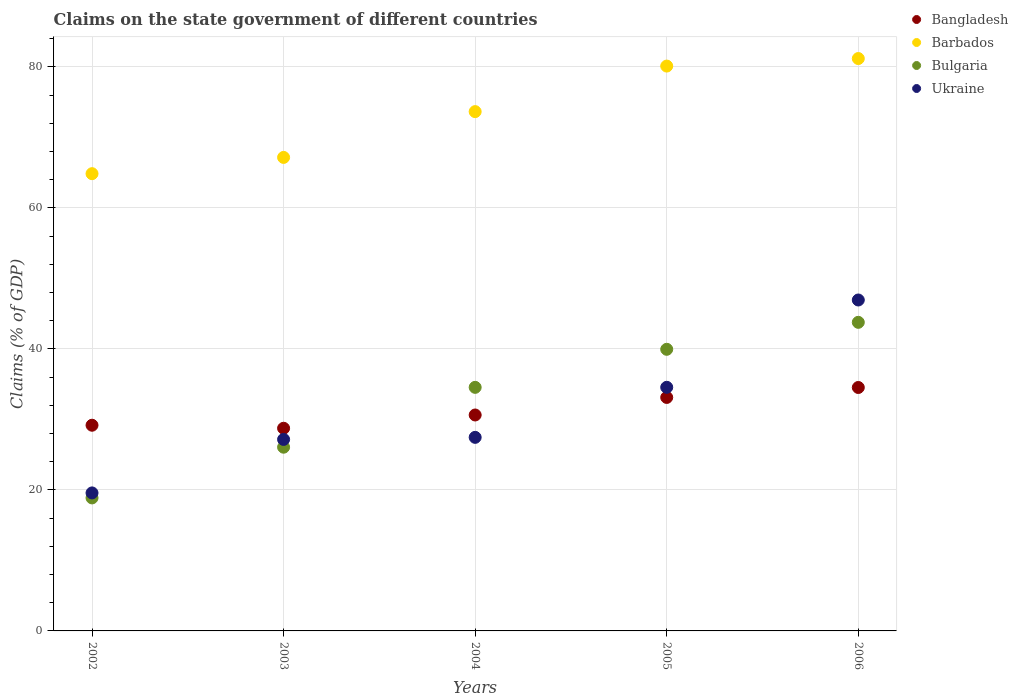How many different coloured dotlines are there?
Offer a terse response. 4. What is the percentage of GDP claimed on the state government in Ukraine in 2005?
Keep it short and to the point. 34.55. Across all years, what is the maximum percentage of GDP claimed on the state government in Bangladesh?
Your answer should be very brief. 34.52. Across all years, what is the minimum percentage of GDP claimed on the state government in Bangladesh?
Offer a terse response. 28.74. In which year was the percentage of GDP claimed on the state government in Bulgaria minimum?
Provide a succinct answer. 2002. What is the total percentage of GDP claimed on the state government in Bangladesh in the graph?
Make the answer very short. 156.18. What is the difference between the percentage of GDP claimed on the state government in Bulgaria in 2002 and that in 2005?
Make the answer very short. -21.08. What is the difference between the percentage of GDP claimed on the state government in Barbados in 2004 and the percentage of GDP claimed on the state government in Ukraine in 2003?
Provide a short and direct response. 46.49. What is the average percentage of GDP claimed on the state government in Bulgaria per year?
Ensure brevity in your answer.  32.63. In the year 2006, what is the difference between the percentage of GDP claimed on the state government in Bulgaria and percentage of GDP claimed on the state government in Bangladesh?
Offer a terse response. 9.24. What is the ratio of the percentage of GDP claimed on the state government in Ukraine in 2002 to that in 2004?
Ensure brevity in your answer.  0.71. What is the difference between the highest and the second highest percentage of GDP claimed on the state government in Bangladesh?
Keep it short and to the point. 1.41. What is the difference between the highest and the lowest percentage of GDP claimed on the state government in Bangladesh?
Offer a terse response. 5.78. In how many years, is the percentage of GDP claimed on the state government in Barbados greater than the average percentage of GDP claimed on the state government in Barbados taken over all years?
Offer a terse response. 3. Is it the case that in every year, the sum of the percentage of GDP claimed on the state government in Barbados and percentage of GDP claimed on the state government in Ukraine  is greater than the sum of percentage of GDP claimed on the state government in Bulgaria and percentage of GDP claimed on the state government in Bangladesh?
Your answer should be compact. Yes. Are the values on the major ticks of Y-axis written in scientific E-notation?
Offer a terse response. No. Does the graph contain grids?
Provide a short and direct response. Yes. How are the legend labels stacked?
Offer a terse response. Vertical. What is the title of the graph?
Your answer should be very brief. Claims on the state government of different countries. What is the label or title of the Y-axis?
Your response must be concise. Claims (% of GDP). What is the Claims (% of GDP) of Bangladesh in 2002?
Offer a terse response. 29.17. What is the Claims (% of GDP) of Barbados in 2002?
Provide a succinct answer. 64.85. What is the Claims (% of GDP) in Bulgaria in 2002?
Make the answer very short. 18.86. What is the Claims (% of GDP) of Ukraine in 2002?
Make the answer very short. 19.57. What is the Claims (% of GDP) of Bangladesh in 2003?
Your answer should be compact. 28.74. What is the Claims (% of GDP) in Barbados in 2003?
Your answer should be compact. 67.15. What is the Claims (% of GDP) in Bulgaria in 2003?
Offer a very short reply. 26.06. What is the Claims (% of GDP) of Ukraine in 2003?
Your answer should be very brief. 27.16. What is the Claims (% of GDP) of Bangladesh in 2004?
Give a very brief answer. 30.62. What is the Claims (% of GDP) in Barbados in 2004?
Provide a short and direct response. 73.65. What is the Claims (% of GDP) in Bulgaria in 2004?
Ensure brevity in your answer.  34.54. What is the Claims (% of GDP) of Ukraine in 2004?
Offer a very short reply. 27.45. What is the Claims (% of GDP) of Bangladesh in 2005?
Provide a succinct answer. 33.11. What is the Claims (% of GDP) of Barbados in 2005?
Your response must be concise. 80.11. What is the Claims (% of GDP) of Bulgaria in 2005?
Offer a very short reply. 39.94. What is the Claims (% of GDP) in Ukraine in 2005?
Provide a short and direct response. 34.55. What is the Claims (% of GDP) in Bangladesh in 2006?
Provide a succinct answer. 34.52. What is the Claims (% of GDP) of Barbados in 2006?
Keep it short and to the point. 81.18. What is the Claims (% of GDP) of Bulgaria in 2006?
Your answer should be very brief. 43.77. What is the Claims (% of GDP) in Ukraine in 2006?
Make the answer very short. 46.93. Across all years, what is the maximum Claims (% of GDP) of Bangladesh?
Your answer should be compact. 34.52. Across all years, what is the maximum Claims (% of GDP) in Barbados?
Provide a short and direct response. 81.18. Across all years, what is the maximum Claims (% of GDP) of Bulgaria?
Provide a succinct answer. 43.77. Across all years, what is the maximum Claims (% of GDP) in Ukraine?
Your answer should be very brief. 46.93. Across all years, what is the minimum Claims (% of GDP) in Bangladesh?
Your answer should be compact. 28.74. Across all years, what is the minimum Claims (% of GDP) in Barbados?
Provide a short and direct response. 64.85. Across all years, what is the minimum Claims (% of GDP) of Bulgaria?
Offer a very short reply. 18.86. Across all years, what is the minimum Claims (% of GDP) of Ukraine?
Keep it short and to the point. 19.57. What is the total Claims (% of GDP) in Bangladesh in the graph?
Your answer should be compact. 156.18. What is the total Claims (% of GDP) in Barbados in the graph?
Provide a short and direct response. 366.94. What is the total Claims (% of GDP) in Bulgaria in the graph?
Offer a very short reply. 163.17. What is the total Claims (% of GDP) in Ukraine in the graph?
Give a very brief answer. 155.67. What is the difference between the Claims (% of GDP) in Bangladesh in 2002 and that in 2003?
Your answer should be compact. 0.43. What is the difference between the Claims (% of GDP) in Barbados in 2002 and that in 2003?
Your answer should be very brief. -2.31. What is the difference between the Claims (% of GDP) in Bulgaria in 2002 and that in 2003?
Your response must be concise. -7.19. What is the difference between the Claims (% of GDP) of Ukraine in 2002 and that in 2003?
Offer a terse response. -7.59. What is the difference between the Claims (% of GDP) of Bangladesh in 2002 and that in 2004?
Offer a terse response. -1.45. What is the difference between the Claims (% of GDP) in Barbados in 2002 and that in 2004?
Offer a terse response. -8.8. What is the difference between the Claims (% of GDP) in Bulgaria in 2002 and that in 2004?
Your answer should be very brief. -15.68. What is the difference between the Claims (% of GDP) in Ukraine in 2002 and that in 2004?
Make the answer very short. -7.88. What is the difference between the Claims (% of GDP) in Bangladesh in 2002 and that in 2005?
Give a very brief answer. -3.94. What is the difference between the Claims (% of GDP) of Barbados in 2002 and that in 2005?
Keep it short and to the point. -15.26. What is the difference between the Claims (% of GDP) in Bulgaria in 2002 and that in 2005?
Keep it short and to the point. -21.08. What is the difference between the Claims (% of GDP) of Ukraine in 2002 and that in 2005?
Make the answer very short. -14.98. What is the difference between the Claims (% of GDP) in Bangladesh in 2002 and that in 2006?
Your answer should be very brief. -5.35. What is the difference between the Claims (% of GDP) in Barbados in 2002 and that in 2006?
Keep it short and to the point. -16.33. What is the difference between the Claims (% of GDP) in Bulgaria in 2002 and that in 2006?
Make the answer very short. -24.9. What is the difference between the Claims (% of GDP) in Ukraine in 2002 and that in 2006?
Make the answer very short. -27.36. What is the difference between the Claims (% of GDP) in Bangladesh in 2003 and that in 2004?
Your response must be concise. -1.88. What is the difference between the Claims (% of GDP) of Barbados in 2003 and that in 2004?
Make the answer very short. -6.5. What is the difference between the Claims (% of GDP) in Bulgaria in 2003 and that in 2004?
Give a very brief answer. -8.49. What is the difference between the Claims (% of GDP) in Ukraine in 2003 and that in 2004?
Your response must be concise. -0.29. What is the difference between the Claims (% of GDP) of Bangladesh in 2003 and that in 2005?
Your answer should be compact. -4.37. What is the difference between the Claims (% of GDP) in Barbados in 2003 and that in 2005?
Your answer should be compact. -12.95. What is the difference between the Claims (% of GDP) in Bulgaria in 2003 and that in 2005?
Your answer should be very brief. -13.88. What is the difference between the Claims (% of GDP) of Ukraine in 2003 and that in 2005?
Your answer should be very brief. -7.39. What is the difference between the Claims (% of GDP) in Bangladesh in 2003 and that in 2006?
Your answer should be compact. -5.78. What is the difference between the Claims (% of GDP) of Barbados in 2003 and that in 2006?
Your response must be concise. -14.02. What is the difference between the Claims (% of GDP) of Bulgaria in 2003 and that in 2006?
Your answer should be compact. -17.71. What is the difference between the Claims (% of GDP) of Ukraine in 2003 and that in 2006?
Ensure brevity in your answer.  -19.77. What is the difference between the Claims (% of GDP) of Bangladesh in 2004 and that in 2005?
Your answer should be very brief. -2.49. What is the difference between the Claims (% of GDP) of Barbados in 2004 and that in 2005?
Your answer should be very brief. -6.46. What is the difference between the Claims (% of GDP) in Bulgaria in 2004 and that in 2005?
Provide a short and direct response. -5.4. What is the difference between the Claims (% of GDP) of Ukraine in 2004 and that in 2005?
Your response must be concise. -7.1. What is the difference between the Claims (% of GDP) of Bangladesh in 2004 and that in 2006?
Provide a succinct answer. -3.9. What is the difference between the Claims (% of GDP) in Barbados in 2004 and that in 2006?
Make the answer very short. -7.53. What is the difference between the Claims (% of GDP) of Bulgaria in 2004 and that in 2006?
Offer a terse response. -9.22. What is the difference between the Claims (% of GDP) in Ukraine in 2004 and that in 2006?
Provide a short and direct response. -19.48. What is the difference between the Claims (% of GDP) of Bangladesh in 2005 and that in 2006?
Make the answer very short. -1.41. What is the difference between the Claims (% of GDP) of Barbados in 2005 and that in 2006?
Your answer should be very brief. -1.07. What is the difference between the Claims (% of GDP) in Bulgaria in 2005 and that in 2006?
Your answer should be compact. -3.82. What is the difference between the Claims (% of GDP) in Ukraine in 2005 and that in 2006?
Provide a succinct answer. -12.38. What is the difference between the Claims (% of GDP) of Bangladesh in 2002 and the Claims (% of GDP) of Barbados in 2003?
Offer a very short reply. -37.98. What is the difference between the Claims (% of GDP) of Bangladesh in 2002 and the Claims (% of GDP) of Bulgaria in 2003?
Provide a short and direct response. 3.12. What is the difference between the Claims (% of GDP) of Bangladesh in 2002 and the Claims (% of GDP) of Ukraine in 2003?
Keep it short and to the point. 2.01. What is the difference between the Claims (% of GDP) in Barbados in 2002 and the Claims (% of GDP) in Bulgaria in 2003?
Offer a terse response. 38.79. What is the difference between the Claims (% of GDP) of Barbados in 2002 and the Claims (% of GDP) of Ukraine in 2003?
Provide a succinct answer. 37.69. What is the difference between the Claims (% of GDP) in Bulgaria in 2002 and the Claims (% of GDP) in Ukraine in 2003?
Keep it short and to the point. -8.3. What is the difference between the Claims (% of GDP) of Bangladesh in 2002 and the Claims (% of GDP) of Barbados in 2004?
Offer a terse response. -44.48. What is the difference between the Claims (% of GDP) of Bangladesh in 2002 and the Claims (% of GDP) of Bulgaria in 2004?
Your answer should be very brief. -5.37. What is the difference between the Claims (% of GDP) of Bangladesh in 2002 and the Claims (% of GDP) of Ukraine in 2004?
Give a very brief answer. 1.72. What is the difference between the Claims (% of GDP) in Barbados in 2002 and the Claims (% of GDP) in Bulgaria in 2004?
Give a very brief answer. 30.3. What is the difference between the Claims (% of GDP) of Barbados in 2002 and the Claims (% of GDP) of Ukraine in 2004?
Ensure brevity in your answer.  37.4. What is the difference between the Claims (% of GDP) in Bulgaria in 2002 and the Claims (% of GDP) in Ukraine in 2004?
Your answer should be compact. -8.59. What is the difference between the Claims (% of GDP) of Bangladesh in 2002 and the Claims (% of GDP) of Barbados in 2005?
Your answer should be compact. -50.94. What is the difference between the Claims (% of GDP) in Bangladesh in 2002 and the Claims (% of GDP) in Bulgaria in 2005?
Offer a terse response. -10.77. What is the difference between the Claims (% of GDP) of Bangladesh in 2002 and the Claims (% of GDP) of Ukraine in 2005?
Your response must be concise. -5.38. What is the difference between the Claims (% of GDP) of Barbados in 2002 and the Claims (% of GDP) of Bulgaria in 2005?
Provide a succinct answer. 24.91. What is the difference between the Claims (% of GDP) of Barbados in 2002 and the Claims (% of GDP) of Ukraine in 2005?
Give a very brief answer. 30.3. What is the difference between the Claims (% of GDP) in Bulgaria in 2002 and the Claims (% of GDP) in Ukraine in 2005?
Provide a short and direct response. -15.69. What is the difference between the Claims (% of GDP) of Bangladesh in 2002 and the Claims (% of GDP) of Barbados in 2006?
Your answer should be compact. -52.01. What is the difference between the Claims (% of GDP) of Bangladesh in 2002 and the Claims (% of GDP) of Bulgaria in 2006?
Keep it short and to the point. -14.59. What is the difference between the Claims (% of GDP) in Bangladesh in 2002 and the Claims (% of GDP) in Ukraine in 2006?
Give a very brief answer. -17.76. What is the difference between the Claims (% of GDP) in Barbados in 2002 and the Claims (% of GDP) in Bulgaria in 2006?
Provide a succinct answer. 21.08. What is the difference between the Claims (% of GDP) in Barbados in 2002 and the Claims (% of GDP) in Ukraine in 2006?
Your response must be concise. 17.91. What is the difference between the Claims (% of GDP) in Bulgaria in 2002 and the Claims (% of GDP) in Ukraine in 2006?
Make the answer very short. -28.07. What is the difference between the Claims (% of GDP) of Bangladesh in 2003 and the Claims (% of GDP) of Barbados in 2004?
Provide a succinct answer. -44.91. What is the difference between the Claims (% of GDP) in Bangladesh in 2003 and the Claims (% of GDP) in Bulgaria in 2004?
Provide a succinct answer. -5.8. What is the difference between the Claims (% of GDP) of Bangladesh in 2003 and the Claims (% of GDP) of Ukraine in 2004?
Offer a terse response. 1.29. What is the difference between the Claims (% of GDP) in Barbados in 2003 and the Claims (% of GDP) in Bulgaria in 2004?
Your answer should be compact. 32.61. What is the difference between the Claims (% of GDP) of Barbados in 2003 and the Claims (% of GDP) of Ukraine in 2004?
Offer a terse response. 39.7. What is the difference between the Claims (% of GDP) in Bulgaria in 2003 and the Claims (% of GDP) in Ukraine in 2004?
Give a very brief answer. -1.4. What is the difference between the Claims (% of GDP) of Bangladesh in 2003 and the Claims (% of GDP) of Barbados in 2005?
Your answer should be very brief. -51.37. What is the difference between the Claims (% of GDP) in Bangladesh in 2003 and the Claims (% of GDP) in Bulgaria in 2005?
Offer a terse response. -11.2. What is the difference between the Claims (% of GDP) of Bangladesh in 2003 and the Claims (% of GDP) of Ukraine in 2005?
Your response must be concise. -5.81. What is the difference between the Claims (% of GDP) in Barbados in 2003 and the Claims (% of GDP) in Bulgaria in 2005?
Your answer should be very brief. 27.21. What is the difference between the Claims (% of GDP) in Barbados in 2003 and the Claims (% of GDP) in Ukraine in 2005?
Your response must be concise. 32.6. What is the difference between the Claims (% of GDP) of Bulgaria in 2003 and the Claims (% of GDP) of Ukraine in 2005?
Your response must be concise. -8.49. What is the difference between the Claims (% of GDP) of Bangladesh in 2003 and the Claims (% of GDP) of Barbados in 2006?
Offer a very short reply. -52.43. What is the difference between the Claims (% of GDP) of Bangladesh in 2003 and the Claims (% of GDP) of Bulgaria in 2006?
Offer a terse response. -15.02. What is the difference between the Claims (% of GDP) of Bangladesh in 2003 and the Claims (% of GDP) of Ukraine in 2006?
Provide a short and direct response. -18.19. What is the difference between the Claims (% of GDP) of Barbados in 2003 and the Claims (% of GDP) of Bulgaria in 2006?
Give a very brief answer. 23.39. What is the difference between the Claims (% of GDP) in Barbados in 2003 and the Claims (% of GDP) in Ukraine in 2006?
Keep it short and to the point. 20.22. What is the difference between the Claims (% of GDP) of Bulgaria in 2003 and the Claims (% of GDP) of Ukraine in 2006?
Provide a short and direct response. -20.88. What is the difference between the Claims (% of GDP) in Bangladesh in 2004 and the Claims (% of GDP) in Barbados in 2005?
Provide a succinct answer. -49.48. What is the difference between the Claims (% of GDP) in Bangladesh in 2004 and the Claims (% of GDP) in Bulgaria in 2005?
Ensure brevity in your answer.  -9.32. What is the difference between the Claims (% of GDP) of Bangladesh in 2004 and the Claims (% of GDP) of Ukraine in 2005?
Your answer should be very brief. -3.93. What is the difference between the Claims (% of GDP) of Barbados in 2004 and the Claims (% of GDP) of Bulgaria in 2005?
Provide a short and direct response. 33.71. What is the difference between the Claims (% of GDP) in Barbados in 2004 and the Claims (% of GDP) in Ukraine in 2005?
Make the answer very short. 39.1. What is the difference between the Claims (% of GDP) of Bulgaria in 2004 and the Claims (% of GDP) of Ukraine in 2005?
Your answer should be compact. -0.01. What is the difference between the Claims (% of GDP) in Bangladesh in 2004 and the Claims (% of GDP) in Barbados in 2006?
Provide a succinct answer. -50.55. What is the difference between the Claims (% of GDP) in Bangladesh in 2004 and the Claims (% of GDP) in Bulgaria in 2006?
Offer a terse response. -13.14. What is the difference between the Claims (% of GDP) of Bangladesh in 2004 and the Claims (% of GDP) of Ukraine in 2006?
Make the answer very short. -16.31. What is the difference between the Claims (% of GDP) of Barbados in 2004 and the Claims (% of GDP) of Bulgaria in 2006?
Your answer should be very brief. 29.88. What is the difference between the Claims (% of GDP) in Barbados in 2004 and the Claims (% of GDP) in Ukraine in 2006?
Your answer should be compact. 26.72. What is the difference between the Claims (% of GDP) in Bulgaria in 2004 and the Claims (% of GDP) in Ukraine in 2006?
Your answer should be very brief. -12.39. What is the difference between the Claims (% of GDP) of Bangladesh in 2005 and the Claims (% of GDP) of Barbados in 2006?
Your answer should be very brief. -48.06. What is the difference between the Claims (% of GDP) of Bangladesh in 2005 and the Claims (% of GDP) of Bulgaria in 2006?
Your answer should be compact. -10.65. What is the difference between the Claims (% of GDP) in Bangladesh in 2005 and the Claims (% of GDP) in Ukraine in 2006?
Offer a terse response. -13.82. What is the difference between the Claims (% of GDP) in Barbados in 2005 and the Claims (% of GDP) in Bulgaria in 2006?
Keep it short and to the point. 36.34. What is the difference between the Claims (% of GDP) in Barbados in 2005 and the Claims (% of GDP) in Ukraine in 2006?
Provide a short and direct response. 33.18. What is the difference between the Claims (% of GDP) of Bulgaria in 2005 and the Claims (% of GDP) of Ukraine in 2006?
Your answer should be very brief. -6.99. What is the average Claims (% of GDP) in Bangladesh per year?
Your answer should be very brief. 31.24. What is the average Claims (% of GDP) in Barbados per year?
Offer a terse response. 73.39. What is the average Claims (% of GDP) of Bulgaria per year?
Your answer should be very brief. 32.63. What is the average Claims (% of GDP) of Ukraine per year?
Keep it short and to the point. 31.13. In the year 2002, what is the difference between the Claims (% of GDP) of Bangladesh and Claims (% of GDP) of Barbados?
Your answer should be compact. -35.68. In the year 2002, what is the difference between the Claims (% of GDP) of Bangladesh and Claims (% of GDP) of Bulgaria?
Ensure brevity in your answer.  10.31. In the year 2002, what is the difference between the Claims (% of GDP) of Bangladesh and Claims (% of GDP) of Ukraine?
Keep it short and to the point. 9.6. In the year 2002, what is the difference between the Claims (% of GDP) of Barbados and Claims (% of GDP) of Bulgaria?
Your response must be concise. 45.99. In the year 2002, what is the difference between the Claims (% of GDP) of Barbados and Claims (% of GDP) of Ukraine?
Provide a succinct answer. 45.28. In the year 2002, what is the difference between the Claims (% of GDP) in Bulgaria and Claims (% of GDP) in Ukraine?
Provide a short and direct response. -0.71. In the year 2003, what is the difference between the Claims (% of GDP) in Bangladesh and Claims (% of GDP) in Barbados?
Offer a terse response. -38.41. In the year 2003, what is the difference between the Claims (% of GDP) of Bangladesh and Claims (% of GDP) of Bulgaria?
Your response must be concise. 2.69. In the year 2003, what is the difference between the Claims (% of GDP) of Bangladesh and Claims (% of GDP) of Ukraine?
Your answer should be compact. 1.58. In the year 2003, what is the difference between the Claims (% of GDP) of Barbados and Claims (% of GDP) of Bulgaria?
Make the answer very short. 41.1. In the year 2003, what is the difference between the Claims (% of GDP) in Barbados and Claims (% of GDP) in Ukraine?
Your answer should be very brief. 40. In the year 2003, what is the difference between the Claims (% of GDP) in Bulgaria and Claims (% of GDP) in Ukraine?
Make the answer very short. -1.1. In the year 2004, what is the difference between the Claims (% of GDP) of Bangladesh and Claims (% of GDP) of Barbados?
Keep it short and to the point. -43.03. In the year 2004, what is the difference between the Claims (% of GDP) of Bangladesh and Claims (% of GDP) of Bulgaria?
Keep it short and to the point. -3.92. In the year 2004, what is the difference between the Claims (% of GDP) of Bangladesh and Claims (% of GDP) of Ukraine?
Provide a succinct answer. 3.17. In the year 2004, what is the difference between the Claims (% of GDP) of Barbados and Claims (% of GDP) of Bulgaria?
Your answer should be compact. 39.11. In the year 2004, what is the difference between the Claims (% of GDP) in Barbados and Claims (% of GDP) in Ukraine?
Give a very brief answer. 46.2. In the year 2004, what is the difference between the Claims (% of GDP) of Bulgaria and Claims (% of GDP) of Ukraine?
Your answer should be very brief. 7.09. In the year 2005, what is the difference between the Claims (% of GDP) of Bangladesh and Claims (% of GDP) of Barbados?
Your response must be concise. -46.99. In the year 2005, what is the difference between the Claims (% of GDP) in Bangladesh and Claims (% of GDP) in Bulgaria?
Your response must be concise. -6.83. In the year 2005, what is the difference between the Claims (% of GDP) of Bangladesh and Claims (% of GDP) of Ukraine?
Make the answer very short. -1.44. In the year 2005, what is the difference between the Claims (% of GDP) of Barbados and Claims (% of GDP) of Bulgaria?
Give a very brief answer. 40.17. In the year 2005, what is the difference between the Claims (% of GDP) of Barbados and Claims (% of GDP) of Ukraine?
Give a very brief answer. 45.56. In the year 2005, what is the difference between the Claims (% of GDP) in Bulgaria and Claims (% of GDP) in Ukraine?
Ensure brevity in your answer.  5.39. In the year 2006, what is the difference between the Claims (% of GDP) of Bangladesh and Claims (% of GDP) of Barbados?
Keep it short and to the point. -46.65. In the year 2006, what is the difference between the Claims (% of GDP) in Bangladesh and Claims (% of GDP) in Bulgaria?
Offer a terse response. -9.24. In the year 2006, what is the difference between the Claims (% of GDP) of Bangladesh and Claims (% of GDP) of Ukraine?
Provide a succinct answer. -12.41. In the year 2006, what is the difference between the Claims (% of GDP) in Barbados and Claims (% of GDP) in Bulgaria?
Your response must be concise. 37.41. In the year 2006, what is the difference between the Claims (% of GDP) of Barbados and Claims (% of GDP) of Ukraine?
Offer a terse response. 34.24. In the year 2006, what is the difference between the Claims (% of GDP) of Bulgaria and Claims (% of GDP) of Ukraine?
Offer a terse response. -3.17. What is the ratio of the Claims (% of GDP) of Bangladesh in 2002 to that in 2003?
Provide a short and direct response. 1.01. What is the ratio of the Claims (% of GDP) of Barbados in 2002 to that in 2003?
Make the answer very short. 0.97. What is the ratio of the Claims (% of GDP) of Bulgaria in 2002 to that in 2003?
Your response must be concise. 0.72. What is the ratio of the Claims (% of GDP) in Ukraine in 2002 to that in 2003?
Ensure brevity in your answer.  0.72. What is the ratio of the Claims (% of GDP) of Bangladesh in 2002 to that in 2004?
Give a very brief answer. 0.95. What is the ratio of the Claims (% of GDP) of Barbados in 2002 to that in 2004?
Provide a short and direct response. 0.88. What is the ratio of the Claims (% of GDP) of Bulgaria in 2002 to that in 2004?
Your response must be concise. 0.55. What is the ratio of the Claims (% of GDP) of Ukraine in 2002 to that in 2004?
Give a very brief answer. 0.71. What is the ratio of the Claims (% of GDP) of Bangladesh in 2002 to that in 2005?
Keep it short and to the point. 0.88. What is the ratio of the Claims (% of GDP) of Barbados in 2002 to that in 2005?
Make the answer very short. 0.81. What is the ratio of the Claims (% of GDP) in Bulgaria in 2002 to that in 2005?
Offer a very short reply. 0.47. What is the ratio of the Claims (% of GDP) in Ukraine in 2002 to that in 2005?
Provide a short and direct response. 0.57. What is the ratio of the Claims (% of GDP) of Bangladesh in 2002 to that in 2006?
Give a very brief answer. 0.84. What is the ratio of the Claims (% of GDP) of Barbados in 2002 to that in 2006?
Provide a short and direct response. 0.8. What is the ratio of the Claims (% of GDP) in Bulgaria in 2002 to that in 2006?
Ensure brevity in your answer.  0.43. What is the ratio of the Claims (% of GDP) in Ukraine in 2002 to that in 2006?
Provide a succinct answer. 0.42. What is the ratio of the Claims (% of GDP) in Bangladesh in 2003 to that in 2004?
Your answer should be compact. 0.94. What is the ratio of the Claims (% of GDP) of Barbados in 2003 to that in 2004?
Give a very brief answer. 0.91. What is the ratio of the Claims (% of GDP) of Bulgaria in 2003 to that in 2004?
Offer a very short reply. 0.75. What is the ratio of the Claims (% of GDP) of Ukraine in 2003 to that in 2004?
Ensure brevity in your answer.  0.99. What is the ratio of the Claims (% of GDP) in Bangladesh in 2003 to that in 2005?
Offer a terse response. 0.87. What is the ratio of the Claims (% of GDP) in Barbados in 2003 to that in 2005?
Provide a short and direct response. 0.84. What is the ratio of the Claims (% of GDP) in Bulgaria in 2003 to that in 2005?
Offer a very short reply. 0.65. What is the ratio of the Claims (% of GDP) of Ukraine in 2003 to that in 2005?
Your answer should be compact. 0.79. What is the ratio of the Claims (% of GDP) of Bangladesh in 2003 to that in 2006?
Ensure brevity in your answer.  0.83. What is the ratio of the Claims (% of GDP) in Barbados in 2003 to that in 2006?
Your response must be concise. 0.83. What is the ratio of the Claims (% of GDP) in Bulgaria in 2003 to that in 2006?
Give a very brief answer. 0.6. What is the ratio of the Claims (% of GDP) of Ukraine in 2003 to that in 2006?
Your answer should be very brief. 0.58. What is the ratio of the Claims (% of GDP) of Bangladesh in 2004 to that in 2005?
Provide a succinct answer. 0.92. What is the ratio of the Claims (% of GDP) in Barbados in 2004 to that in 2005?
Your answer should be very brief. 0.92. What is the ratio of the Claims (% of GDP) of Bulgaria in 2004 to that in 2005?
Provide a short and direct response. 0.86. What is the ratio of the Claims (% of GDP) in Ukraine in 2004 to that in 2005?
Provide a short and direct response. 0.79. What is the ratio of the Claims (% of GDP) of Bangladesh in 2004 to that in 2006?
Offer a very short reply. 0.89. What is the ratio of the Claims (% of GDP) in Barbados in 2004 to that in 2006?
Provide a short and direct response. 0.91. What is the ratio of the Claims (% of GDP) of Bulgaria in 2004 to that in 2006?
Make the answer very short. 0.79. What is the ratio of the Claims (% of GDP) of Ukraine in 2004 to that in 2006?
Your response must be concise. 0.58. What is the ratio of the Claims (% of GDP) in Bangladesh in 2005 to that in 2006?
Provide a short and direct response. 0.96. What is the ratio of the Claims (% of GDP) of Barbados in 2005 to that in 2006?
Ensure brevity in your answer.  0.99. What is the ratio of the Claims (% of GDP) in Bulgaria in 2005 to that in 2006?
Give a very brief answer. 0.91. What is the ratio of the Claims (% of GDP) in Ukraine in 2005 to that in 2006?
Provide a succinct answer. 0.74. What is the difference between the highest and the second highest Claims (% of GDP) in Bangladesh?
Provide a succinct answer. 1.41. What is the difference between the highest and the second highest Claims (% of GDP) in Barbados?
Keep it short and to the point. 1.07. What is the difference between the highest and the second highest Claims (% of GDP) in Bulgaria?
Your answer should be compact. 3.82. What is the difference between the highest and the second highest Claims (% of GDP) of Ukraine?
Give a very brief answer. 12.38. What is the difference between the highest and the lowest Claims (% of GDP) of Bangladesh?
Your answer should be very brief. 5.78. What is the difference between the highest and the lowest Claims (% of GDP) in Barbados?
Offer a terse response. 16.33. What is the difference between the highest and the lowest Claims (% of GDP) in Bulgaria?
Make the answer very short. 24.9. What is the difference between the highest and the lowest Claims (% of GDP) in Ukraine?
Keep it short and to the point. 27.36. 